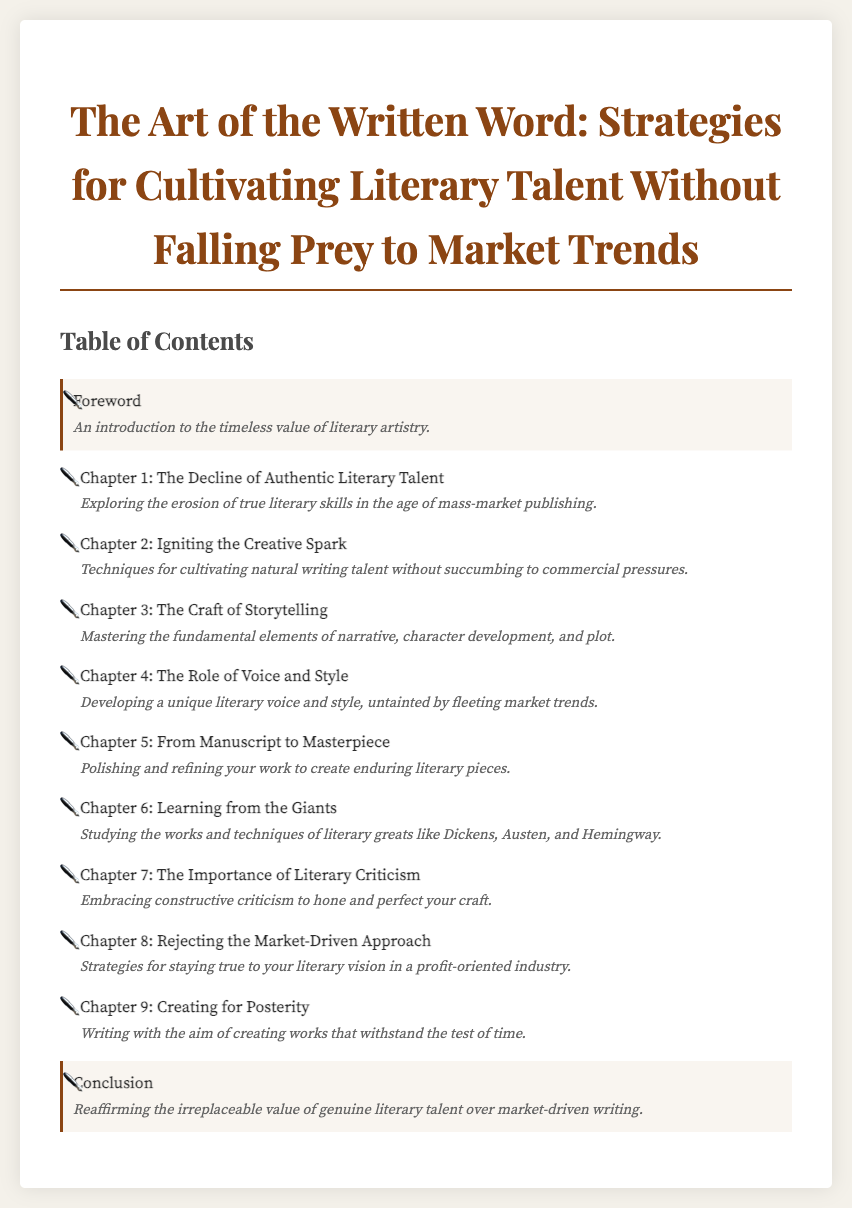What is the title of the book? The title is provided in the header of the document.
Answer: The Art of the Written Word: Strategies for Cultivating Literary Talent Without Falling Prey to Market Trends How many chapters are listed in the Table of Contents? The number of chapters can be counted from the list provided in the document.
Answer: Nine What chapter focuses on voice and style? The chapter title is explicitly stated in the document.
Answer: Chapter 4: The Role of Voice and Style Which chapter discusses learning from literary greats? The document lists chapter titles and their respective focuses, making it easy to answer.
Answer: Chapter 6: Learning from the Giants What is the main theme of the conclusion? The description of the conclusion summarizes its focus as stated in the document.
Answer: The irreplaceable value of genuine literary talent over market-driven writing What chapter addresses the rejection of market-driven approaches? The chapter title indicates its subject matter, as noted in the document.
Answer: Chapter 8: Rejecting the Market-Driven Approach Which chapter provides techniques for igniting creativity? The chapter description highlights its focus on creativity techniques.
Answer: Chapter 2: Igniting the Creative Spark What is emphasized in the chapter about literary criticism? The chapter description specifically outlines the significance of critique in improving craft.
Answer: Constructive criticism to hone and perfect your craft What is the purpose of writing as mentioned in Chapter 9? Chapter 9 provides a description that outlines its purpose in literary creation.
Answer: Creating works that withstand the test of time 